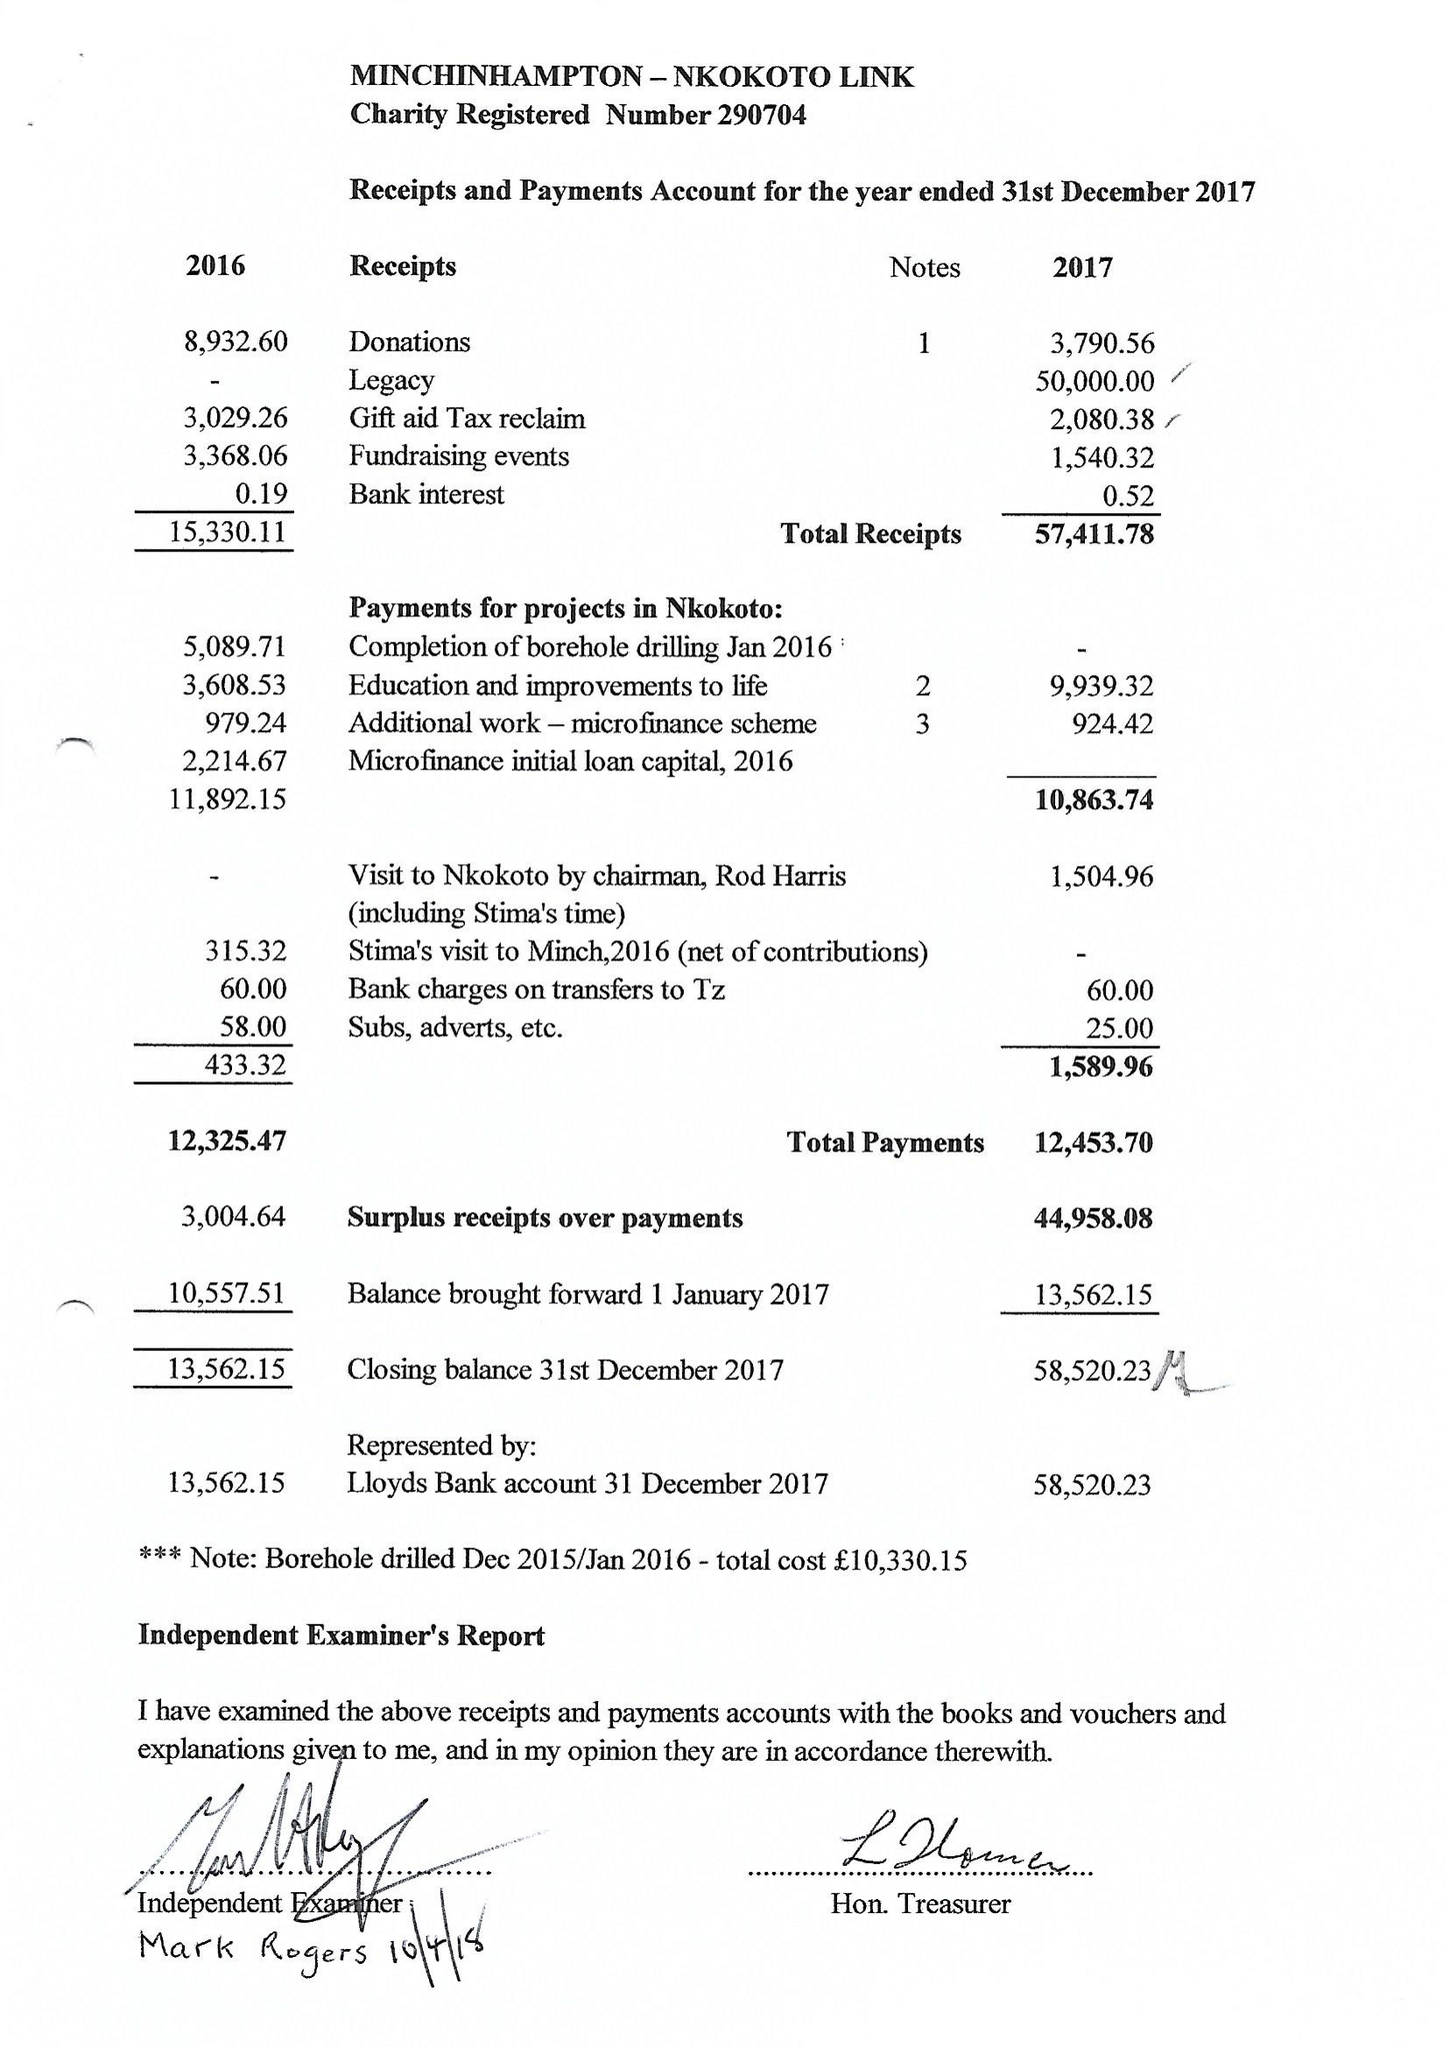What is the value for the charity_number?
Answer the question using a single word or phrase. 290704 